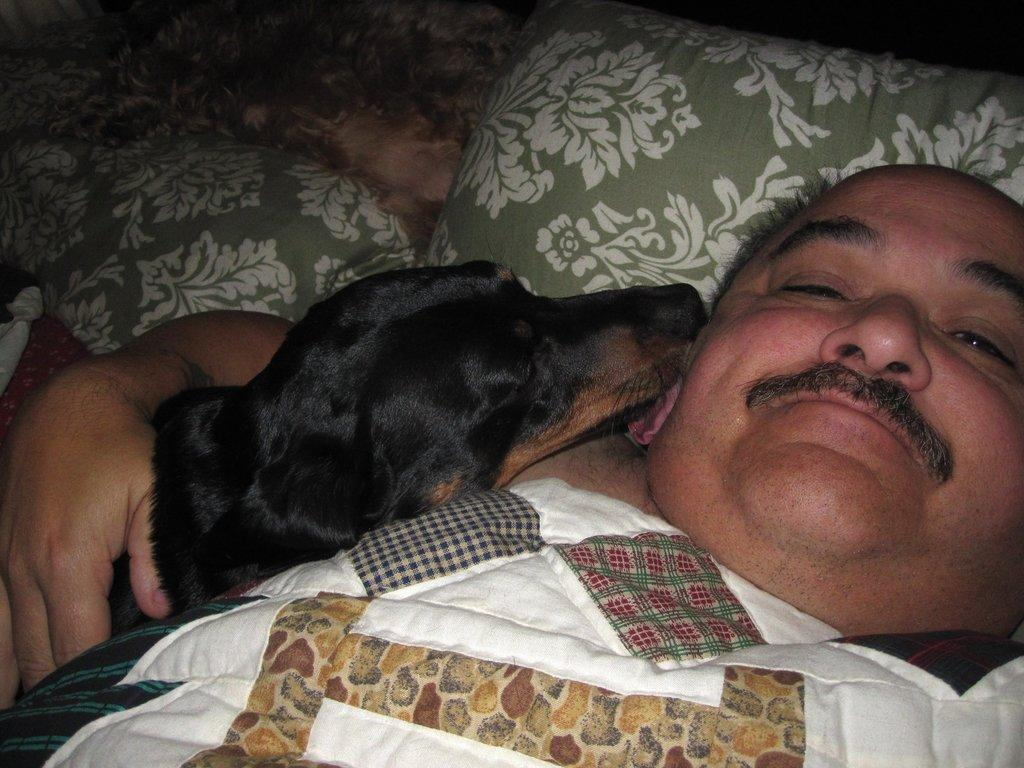Where is the scene of the image taking place? The image is inside a room. What is the man in the image doing? The man is lying on the bed in the image. What is the man holding in his hand? The man is holding a dog in his hand. Can you describe any other objects in the background of the image? There is a pillow visible in the background of the image. What type of mine is visible in the image? There is no mine present in the image; it is set inside a room with a man lying on a bed and holding a dog. 